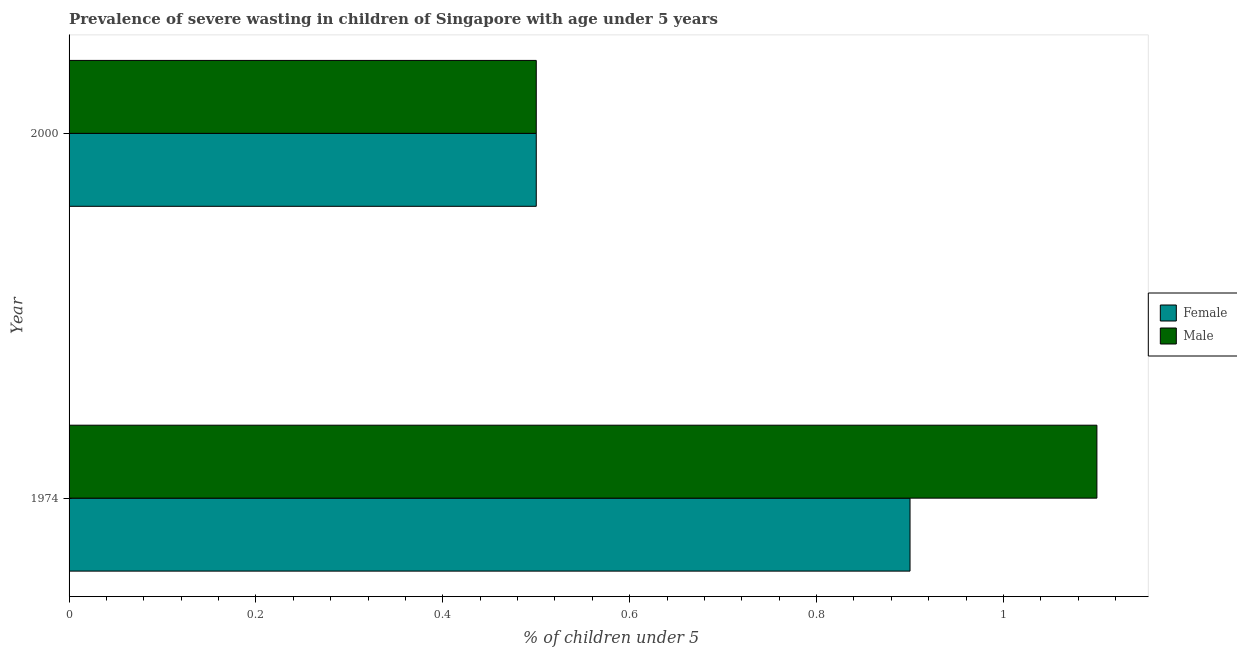Are the number of bars on each tick of the Y-axis equal?
Your response must be concise. Yes. How many bars are there on the 2nd tick from the top?
Your answer should be compact. 2. How many bars are there on the 1st tick from the bottom?
Keep it short and to the point. 2. What is the label of the 1st group of bars from the top?
Offer a terse response. 2000. In how many cases, is the number of bars for a given year not equal to the number of legend labels?
Offer a very short reply. 0. What is the percentage of undernourished female children in 1974?
Your response must be concise. 0.9. Across all years, what is the maximum percentage of undernourished female children?
Your answer should be compact. 0.9. Across all years, what is the minimum percentage of undernourished male children?
Ensure brevity in your answer.  0.5. In which year was the percentage of undernourished male children maximum?
Your response must be concise. 1974. What is the total percentage of undernourished female children in the graph?
Offer a terse response. 1.4. What is the difference between the percentage of undernourished male children in 2000 and the percentage of undernourished female children in 1974?
Provide a short and direct response. -0.4. In the year 2000, what is the difference between the percentage of undernourished female children and percentage of undernourished male children?
Provide a succinct answer. 0. In how many years, is the percentage of undernourished female children greater than 0.4 %?
Your answer should be compact. 2. Is the percentage of undernourished female children in 1974 less than that in 2000?
Keep it short and to the point. No. What does the 2nd bar from the top in 2000 represents?
Provide a succinct answer. Female. What does the 2nd bar from the bottom in 2000 represents?
Your answer should be compact. Male. How many bars are there?
Your answer should be very brief. 4. Are all the bars in the graph horizontal?
Make the answer very short. Yes. How many years are there in the graph?
Make the answer very short. 2. What is the difference between two consecutive major ticks on the X-axis?
Make the answer very short. 0.2. Are the values on the major ticks of X-axis written in scientific E-notation?
Ensure brevity in your answer.  No. How many legend labels are there?
Offer a very short reply. 2. What is the title of the graph?
Give a very brief answer. Prevalence of severe wasting in children of Singapore with age under 5 years. What is the label or title of the X-axis?
Your response must be concise.  % of children under 5. What is the label or title of the Y-axis?
Keep it short and to the point. Year. What is the  % of children under 5 of Female in 1974?
Make the answer very short. 0.9. What is the  % of children under 5 in Male in 1974?
Keep it short and to the point. 1.1. What is the  % of children under 5 in Female in 2000?
Provide a short and direct response. 0.5. What is the  % of children under 5 in Male in 2000?
Offer a very short reply. 0.5. Across all years, what is the maximum  % of children under 5 in Female?
Offer a very short reply. 0.9. Across all years, what is the maximum  % of children under 5 in Male?
Keep it short and to the point. 1.1. Across all years, what is the minimum  % of children under 5 in Female?
Give a very brief answer. 0.5. Across all years, what is the minimum  % of children under 5 in Male?
Offer a very short reply. 0.5. What is the total  % of children under 5 in Female in the graph?
Provide a short and direct response. 1.4. What is the total  % of children under 5 in Male in the graph?
Keep it short and to the point. 1.6. What is the ratio of the  % of children under 5 of Female in 1974 to that in 2000?
Provide a short and direct response. 1.8. What is the ratio of the  % of children under 5 of Male in 1974 to that in 2000?
Ensure brevity in your answer.  2.2. 